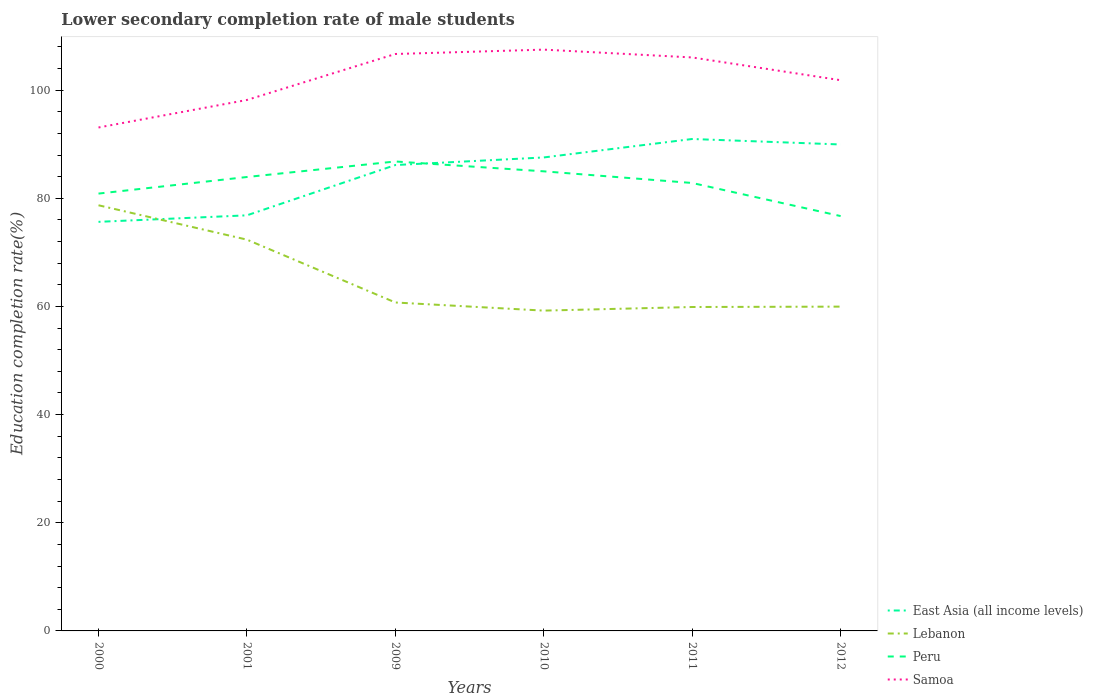How many different coloured lines are there?
Keep it short and to the point. 4. Across all years, what is the maximum lower secondary completion rate of male students in East Asia (all income levels)?
Ensure brevity in your answer.  75.64. In which year was the lower secondary completion rate of male students in East Asia (all income levels) maximum?
Keep it short and to the point. 2000. What is the total lower secondary completion rate of male students in East Asia (all income levels) in the graph?
Provide a short and direct response. -1.4. What is the difference between the highest and the second highest lower secondary completion rate of male students in Lebanon?
Ensure brevity in your answer.  19.48. What is the difference between two consecutive major ticks on the Y-axis?
Provide a short and direct response. 20. Are the values on the major ticks of Y-axis written in scientific E-notation?
Provide a succinct answer. No. Where does the legend appear in the graph?
Give a very brief answer. Bottom right. How many legend labels are there?
Your answer should be compact. 4. What is the title of the graph?
Keep it short and to the point. Lower secondary completion rate of male students. Does "Argentina" appear as one of the legend labels in the graph?
Provide a short and direct response. No. What is the label or title of the X-axis?
Make the answer very short. Years. What is the label or title of the Y-axis?
Provide a short and direct response. Education completion rate(%). What is the Education completion rate(%) in East Asia (all income levels) in 2000?
Make the answer very short. 75.64. What is the Education completion rate(%) of Lebanon in 2000?
Ensure brevity in your answer.  78.71. What is the Education completion rate(%) in Peru in 2000?
Your response must be concise. 80.87. What is the Education completion rate(%) of Samoa in 2000?
Ensure brevity in your answer.  93.09. What is the Education completion rate(%) in East Asia (all income levels) in 2001?
Provide a succinct answer. 76.84. What is the Education completion rate(%) of Lebanon in 2001?
Offer a very short reply. 72.35. What is the Education completion rate(%) in Peru in 2001?
Provide a short and direct response. 83.93. What is the Education completion rate(%) of Samoa in 2001?
Offer a terse response. 98.18. What is the Education completion rate(%) in East Asia (all income levels) in 2009?
Your response must be concise. 86.15. What is the Education completion rate(%) in Lebanon in 2009?
Provide a succinct answer. 60.73. What is the Education completion rate(%) in Peru in 2009?
Your answer should be very brief. 86.8. What is the Education completion rate(%) in Samoa in 2009?
Provide a succinct answer. 106.68. What is the Education completion rate(%) of East Asia (all income levels) in 2010?
Give a very brief answer. 87.55. What is the Education completion rate(%) of Lebanon in 2010?
Offer a terse response. 59.23. What is the Education completion rate(%) in Peru in 2010?
Keep it short and to the point. 84.98. What is the Education completion rate(%) of Samoa in 2010?
Provide a short and direct response. 107.49. What is the Education completion rate(%) in East Asia (all income levels) in 2011?
Make the answer very short. 90.96. What is the Education completion rate(%) in Lebanon in 2011?
Provide a succinct answer. 59.9. What is the Education completion rate(%) of Peru in 2011?
Your response must be concise. 82.83. What is the Education completion rate(%) in Samoa in 2011?
Ensure brevity in your answer.  106.04. What is the Education completion rate(%) in East Asia (all income levels) in 2012?
Your answer should be very brief. 89.95. What is the Education completion rate(%) in Lebanon in 2012?
Ensure brevity in your answer.  59.96. What is the Education completion rate(%) of Peru in 2012?
Give a very brief answer. 76.71. What is the Education completion rate(%) of Samoa in 2012?
Your answer should be compact. 101.83. Across all years, what is the maximum Education completion rate(%) of East Asia (all income levels)?
Provide a short and direct response. 90.96. Across all years, what is the maximum Education completion rate(%) of Lebanon?
Give a very brief answer. 78.71. Across all years, what is the maximum Education completion rate(%) in Peru?
Offer a very short reply. 86.8. Across all years, what is the maximum Education completion rate(%) in Samoa?
Offer a very short reply. 107.49. Across all years, what is the minimum Education completion rate(%) of East Asia (all income levels)?
Provide a short and direct response. 75.64. Across all years, what is the minimum Education completion rate(%) in Lebanon?
Your answer should be very brief. 59.23. Across all years, what is the minimum Education completion rate(%) in Peru?
Your answer should be very brief. 76.71. Across all years, what is the minimum Education completion rate(%) of Samoa?
Your answer should be very brief. 93.09. What is the total Education completion rate(%) in East Asia (all income levels) in the graph?
Your response must be concise. 507.09. What is the total Education completion rate(%) in Lebanon in the graph?
Provide a short and direct response. 390.87. What is the total Education completion rate(%) in Peru in the graph?
Ensure brevity in your answer.  496.12. What is the total Education completion rate(%) of Samoa in the graph?
Provide a succinct answer. 613.3. What is the difference between the Education completion rate(%) of East Asia (all income levels) in 2000 and that in 2001?
Offer a very short reply. -1.2. What is the difference between the Education completion rate(%) of Lebanon in 2000 and that in 2001?
Provide a succinct answer. 6.36. What is the difference between the Education completion rate(%) in Peru in 2000 and that in 2001?
Give a very brief answer. -3.07. What is the difference between the Education completion rate(%) of Samoa in 2000 and that in 2001?
Make the answer very short. -5.09. What is the difference between the Education completion rate(%) in East Asia (all income levels) in 2000 and that in 2009?
Offer a very short reply. -10.5. What is the difference between the Education completion rate(%) in Lebanon in 2000 and that in 2009?
Your answer should be very brief. 17.98. What is the difference between the Education completion rate(%) in Peru in 2000 and that in 2009?
Your answer should be very brief. -5.94. What is the difference between the Education completion rate(%) in Samoa in 2000 and that in 2009?
Ensure brevity in your answer.  -13.59. What is the difference between the Education completion rate(%) in East Asia (all income levels) in 2000 and that in 2010?
Offer a very short reply. -11.91. What is the difference between the Education completion rate(%) of Lebanon in 2000 and that in 2010?
Your response must be concise. 19.48. What is the difference between the Education completion rate(%) of Peru in 2000 and that in 2010?
Make the answer very short. -4.12. What is the difference between the Education completion rate(%) of Samoa in 2000 and that in 2010?
Offer a very short reply. -14.4. What is the difference between the Education completion rate(%) in East Asia (all income levels) in 2000 and that in 2011?
Your answer should be very brief. -15.32. What is the difference between the Education completion rate(%) of Lebanon in 2000 and that in 2011?
Give a very brief answer. 18.81. What is the difference between the Education completion rate(%) of Peru in 2000 and that in 2011?
Provide a short and direct response. -1.96. What is the difference between the Education completion rate(%) in Samoa in 2000 and that in 2011?
Provide a short and direct response. -12.95. What is the difference between the Education completion rate(%) of East Asia (all income levels) in 2000 and that in 2012?
Your answer should be compact. -14.31. What is the difference between the Education completion rate(%) of Lebanon in 2000 and that in 2012?
Offer a terse response. 18.74. What is the difference between the Education completion rate(%) of Peru in 2000 and that in 2012?
Provide a succinct answer. 4.16. What is the difference between the Education completion rate(%) in Samoa in 2000 and that in 2012?
Make the answer very short. -8.74. What is the difference between the Education completion rate(%) in East Asia (all income levels) in 2001 and that in 2009?
Keep it short and to the point. -9.3. What is the difference between the Education completion rate(%) in Lebanon in 2001 and that in 2009?
Provide a short and direct response. 11.62. What is the difference between the Education completion rate(%) in Peru in 2001 and that in 2009?
Make the answer very short. -2.87. What is the difference between the Education completion rate(%) in Samoa in 2001 and that in 2009?
Give a very brief answer. -8.5. What is the difference between the Education completion rate(%) of East Asia (all income levels) in 2001 and that in 2010?
Offer a terse response. -10.7. What is the difference between the Education completion rate(%) in Lebanon in 2001 and that in 2010?
Provide a short and direct response. 13.12. What is the difference between the Education completion rate(%) of Peru in 2001 and that in 2010?
Your answer should be very brief. -1.05. What is the difference between the Education completion rate(%) of Samoa in 2001 and that in 2010?
Your answer should be very brief. -9.31. What is the difference between the Education completion rate(%) of East Asia (all income levels) in 2001 and that in 2011?
Offer a terse response. -14.12. What is the difference between the Education completion rate(%) of Lebanon in 2001 and that in 2011?
Make the answer very short. 12.45. What is the difference between the Education completion rate(%) in Peru in 2001 and that in 2011?
Give a very brief answer. 1.11. What is the difference between the Education completion rate(%) in Samoa in 2001 and that in 2011?
Offer a very short reply. -7.86. What is the difference between the Education completion rate(%) in East Asia (all income levels) in 2001 and that in 2012?
Make the answer very short. -13.1. What is the difference between the Education completion rate(%) in Lebanon in 2001 and that in 2012?
Make the answer very short. 12.39. What is the difference between the Education completion rate(%) of Peru in 2001 and that in 2012?
Your response must be concise. 7.22. What is the difference between the Education completion rate(%) of Samoa in 2001 and that in 2012?
Your answer should be compact. -3.65. What is the difference between the Education completion rate(%) in East Asia (all income levels) in 2009 and that in 2010?
Your answer should be very brief. -1.4. What is the difference between the Education completion rate(%) of Lebanon in 2009 and that in 2010?
Provide a short and direct response. 1.5. What is the difference between the Education completion rate(%) in Peru in 2009 and that in 2010?
Provide a succinct answer. 1.82. What is the difference between the Education completion rate(%) of Samoa in 2009 and that in 2010?
Offer a terse response. -0.81. What is the difference between the Education completion rate(%) of East Asia (all income levels) in 2009 and that in 2011?
Ensure brevity in your answer.  -4.82. What is the difference between the Education completion rate(%) in Lebanon in 2009 and that in 2011?
Give a very brief answer. 0.83. What is the difference between the Education completion rate(%) of Peru in 2009 and that in 2011?
Offer a terse response. 3.98. What is the difference between the Education completion rate(%) in Samoa in 2009 and that in 2011?
Provide a succinct answer. 0.64. What is the difference between the Education completion rate(%) of East Asia (all income levels) in 2009 and that in 2012?
Offer a very short reply. -3.8. What is the difference between the Education completion rate(%) of Lebanon in 2009 and that in 2012?
Your answer should be compact. 0.77. What is the difference between the Education completion rate(%) in Peru in 2009 and that in 2012?
Your answer should be very brief. 10.1. What is the difference between the Education completion rate(%) of Samoa in 2009 and that in 2012?
Offer a terse response. 4.85. What is the difference between the Education completion rate(%) of East Asia (all income levels) in 2010 and that in 2011?
Provide a succinct answer. -3.41. What is the difference between the Education completion rate(%) of Lebanon in 2010 and that in 2011?
Your answer should be compact. -0.67. What is the difference between the Education completion rate(%) of Peru in 2010 and that in 2011?
Ensure brevity in your answer.  2.15. What is the difference between the Education completion rate(%) in Samoa in 2010 and that in 2011?
Your answer should be very brief. 1.45. What is the difference between the Education completion rate(%) of East Asia (all income levels) in 2010 and that in 2012?
Offer a terse response. -2.4. What is the difference between the Education completion rate(%) in Lebanon in 2010 and that in 2012?
Give a very brief answer. -0.74. What is the difference between the Education completion rate(%) of Peru in 2010 and that in 2012?
Keep it short and to the point. 8.27. What is the difference between the Education completion rate(%) of Samoa in 2010 and that in 2012?
Your answer should be compact. 5.66. What is the difference between the Education completion rate(%) in East Asia (all income levels) in 2011 and that in 2012?
Offer a very short reply. 1.01. What is the difference between the Education completion rate(%) of Lebanon in 2011 and that in 2012?
Provide a short and direct response. -0.07. What is the difference between the Education completion rate(%) of Peru in 2011 and that in 2012?
Ensure brevity in your answer.  6.12. What is the difference between the Education completion rate(%) of Samoa in 2011 and that in 2012?
Your answer should be compact. 4.21. What is the difference between the Education completion rate(%) of East Asia (all income levels) in 2000 and the Education completion rate(%) of Lebanon in 2001?
Keep it short and to the point. 3.29. What is the difference between the Education completion rate(%) of East Asia (all income levels) in 2000 and the Education completion rate(%) of Peru in 2001?
Your response must be concise. -8.29. What is the difference between the Education completion rate(%) in East Asia (all income levels) in 2000 and the Education completion rate(%) in Samoa in 2001?
Provide a succinct answer. -22.54. What is the difference between the Education completion rate(%) of Lebanon in 2000 and the Education completion rate(%) of Peru in 2001?
Offer a terse response. -5.23. What is the difference between the Education completion rate(%) of Lebanon in 2000 and the Education completion rate(%) of Samoa in 2001?
Offer a very short reply. -19.47. What is the difference between the Education completion rate(%) of Peru in 2000 and the Education completion rate(%) of Samoa in 2001?
Your response must be concise. -17.31. What is the difference between the Education completion rate(%) in East Asia (all income levels) in 2000 and the Education completion rate(%) in Lebanon in 2009?
Your answer should be very brief. 14.91. What is the difference between the Education completion rate(%) in East Asia (all income levels) in 2000 and the Education completion rate(%) in Peru in 2009?
Offer a very short reply. -11.16. What is the difference between the Education completion rate(%) in East Asia (all income levels) in 2000 and the Education completion rate(%) in Samoa in 2009?
Your answer should be compact. -31.04. What is the difference between the Education completion rate(%) in Lebanon in 2000 and the Education completion rate(%) in Peru in 2009?
Offer a terse response. -8.1. What is the difference between the Education completion rate(%) in Lebanon in 2000 and the Education completion rate(%) in Samoa in 2009?
Offer a very short reply. -27.97. What is the difference between the Education completion rate(%) of Peru in 2000 and the Education completion rate(%) of Samoa in 2009?
Ensure brevity in your answer.  -25.81. What is the difference between the Education completion rate(%) in East Asia (all income levels) in 2000 and the Education completion rate(%) in Lebanon in 2010?
Give a very brief answer. 16.42. What is the difference between the Education completion rate(%) in East Asia (all income levels) in 2000 and the Education completion rate(%) in Peru in 2010?
Your response must be concise. -9.34. What is the difference between the Education completion rate(%) in East Asia (all income levels) in 2000 and the Education completion rate(%) in Samoa in 2010?
Give a very brief answer. -31.84. What is the difference between the Education completion rate(%) of Lebanon in 2000 and the Education completion rate(%) of Peru in 2010?
Your answer should be very brief. -6.28. What is the difference between the Education completion rate(%) in Lebanon in 2000 and the Education completion rate(%) in Samoa in 2010?
Give a very brief answer. -28.78. What is the difference between the Education completion rate(%) in Peru in 2000 and the Education completion rate(%) in Samoa in 2010?
Offer a very short reply. -26.62. What is the difference between the Education completion rate(%) of East Asia (all income levels) in 2000 and the Education completion rate(%) of Lebanon in 2011?
Provide a succinct answer. 15.75. What is the difference between the Education completion rate(%) in East Asia (all income levels) in 2000 and the Education completion rate(%) in Peru in 2011?
Your answer should be very brief. -7.18. What is the difference between the Education completion rate(%) of East Asia (all income levels) in 2000 and the Education completion rate(%) of Samoa in 2011?
Give a very brief answer. -30.4. What is the difference between the Education completion rate(%) of Lebanon in 2000 and the Education completion rate(%) of Peru in 2011?
Provide a short and direct response. -4.12. What is the difference between the Education completion rate(%) of Lebanon in 2000 and the Education completion rate(%) of Samoa in 2011?
Ensure brevity in your answer.  -27.33. What is the difference between the Education completion rate(%) in Peru in 2000 and the Education completion rate(%) in Samoa in 2011?
Ensure brevity in your answer.  -25.17. What is the difference between the Education completion rate(%) of East Asia (all income levels) in 2000 and the Education completion rate(%) of Lebanon in 2012?
Provide a short and direct response. 15.68. What is the difference between the Education completion rate(%) of East Asia (all income levels) in 2000 and the Education completion rate(%) of Peru in 2012?
Provide a short and direct response. -1.07. What is the difference between the Education completion rate(%) in East Asia (all income levels) in 2000 and the Education completion rate(%) in Samoa in 2012?
Your answer should be very brief. -26.19. What is the difference between the Education completion rate(%) in Lebanon in 2000 and the Education completion rate(%) in Peru in 2012?
Give a very brief answer. 2. What is the difference between the Education completion rate(%) of Lebanon in 2000 and the Education completion rate(%) of Samoa in 2012?
Make the answer very short. -23.12. What is the difference between the Education completion rate(%) of Peru in 2000 and the Education completion rate(%) of Samoa in 2012?
Your answer should be compact. -20.96. What is the difference between the Education completion rate(%) of East Asia (all income levels) in 2001 and the Education completion rate(%) of Lebanon in 2009?
Your response must be concise. 16.12. What is the difference between the Education completion rate(%) of East Asia (all income levels) in 2001 and the Education completion rate(%) of Peru in 2009?
Keep it short and to the point. -9.96. What is the difference between the Education completion rate(%) in East Asia (all income levels) in 2001 and the Education completion rate(%) in Samoa in 2009?
Offer a terse response. -29.83. What is the difference between the Education completion rate(%) of Lebanon in 2001 and the Education completion rate(%) of Peru in 2009?
Ensure brevity in your answer.  -14.45. What is the difference between the Education completion rate(%) of Lebanon in 2001 and the Education completion rate(%) of Samoa in 2009?
Make the answer very short. -34.33. What is the difference between the Education completion rate(%) of Peru in 2001 and the Education completion rate(%) of Samoa in 2009?
Your response must be concise. -22.75. What is the difference between the Education completion rate(%) of East Asia (all income levels) in 2001 and the Education completion rate(%) of Lebanon in 2010?
Make the answer very short. 17.62. What is the difference between the Education completion rate(%) of East Asia (all income levels) in 2001 and the Education completion rate(%) of Peru in 2010?
Offer a very short reply. -8.14. What is the difference between the Education completion rate(%) of East Asia (all income levels) in 2001 and the Education completion rate(%) of Samoa in 2010?
Provide a succinct answer. -30.64. What is the difference between the Education completion rate(%) of Lebanon in 2001 and the Education completion rate(%) of Peru in 2010?
Provide a short and direct response. -12.63. What is the difference between the Education completion rate(%) in Lebanon in 2001 and the Education completion rate(%) in Samoa in 2010?
Offer a very short reply. -35.14. What is the difference between the Education completion rate(%) of Peru in 2001 and the Education completion rate(%) of Samoa in 2010?
Ensure brevity in your answer.  -23.55. What is the difference between the Education completion rate(%) of East Asia (all income levels) in 2001 and the Education completion rate(%) of Lebanon in 2011?
Give a very brief answer. 16.95. What is the difference between the Education completion rate(%) in East Asia (all income levels) in 2001 and the Education completion rate(%) in Peru in 2011?
Your answer should be compact. -5.98. What is the difference between the Education completion rate(%) of East Asia (all income levels) in 2001 and the Education completion rate(%) of Samoa in 2011?
Your answer should be very brief. -29.19. What is the difference between the Education completion rate(%) of Lebanon in 2001 and the Education completion rate(%) of Peru in 2011?
Your response must be concise. -10.48. What is the difference between the Education completion rate(%) in Lebanon in 2001 and the Education completion rate(%) in Samoa in 2011?
Your answer should be very brief. -33.69. What is the difference between the Education completion rate(%) of Peru in 2001 and the Education completion rate(%) of Samoa in 2011?
Your answer should be compact. -22.11. What is the difference between the Education completion rate(%) of East Asia (all income levels) in 2001 and the Education completion rate(%) of Lebanon in 2012?
Your response must be concise. 16.88. What is the difference between the Education completion rate(%) in East Asia (all income levels) in 2001 and the Education completion rate(%) in Peru in 2012?
Keep it short and to the point. 0.14. What is the difference between the Education completion rate(%) of East Asia (all income levels) in 2001 and the Education completion rate(%) of Samoa in 2012?
Give a very brief answer. -24.98. What is the difference between the Education completion rate(%) in Lebanon in 2001 and the Education completion rate(%) in Peru in 2012?
Your answer should be compact. -4.36. What is the difference between the Education completion rate(%) in Lebanon in 2001 and the Education completion rate(%) in Samoa in 2012?
Keep it short and to the point. -29.48. What is the difference between the Education completion rate(%) in Peru in 2001 and the Education completion rate(%) in Samoa in 2012?
Offer a very short reply. -17.9. What is the difference between the Education completion rate(%) of East Asia (all income levels) in 2009 and the Education completion rate(%) of Lebanon in 2010?
Provide a short and direct response. 26.92. What is the difference between the Education completion rate(%) of East Asia (all income levels) in 2009 and the Education completion rate(%) of Peru in 2010?
Keep it short and to the point. 1.16. What is the difference between the Education completion rate(%) of East Asia (all income levels) in 2009 and the Education completion rate(%) of Samoa in 2010?
Offer a very short reply. -21.34. What is the difference between the Education completion rate(%) in Lebanon in 2009 and the Education completion rate(%) in Peru in 2010?
Offer a terse response. -24.25. What is the difference between the Education completion rate(%) of Lebanon in 2009 and the Education completion rate(%) of Samoa in 2010?
Ensure brevity in your answer.  -46.76. What is the difference between the Education completion rate(%) in Peru in 2009 and the Education completion rate(%) in Samoa in 2010?
Offer a very short reply. -20.68. What is the difference between the Education completion rate(%) in East Asia (all income levels) in 2009 and the Education completion rate(%) in Lebanon in 2011?
Your answer should be very brief. 26.25. What is the difference between the Education completion rate(%) of East Asia (all income levels) in 2009 and the Education completion rate(%) of Peru in 2011?
Keep it short and to the point. 3.32. What is the difference between the Education completion rate(%) in East Asia (all income levels) in 2009 and the Education completion rate(%) in Samoa in 2011?
Ensure brevity in your answer.  -19.89. What is the difference between the Education completion rate(%) in Lebanon in 2009 and the Education completion rate(%) in Peru in 2011?
Provide a short and direct response. -22.1. What is the difference between the Education completion rate(%) of Lebanon in 2009 and the Education completion rate(%) of Samoa in 2011?
Ensure brevity in your answer.  -45.31. What is the difference between the Education completion rate(%) in Peru in 2009 and the Education completion rate(%) in Samoa in 2011?
Your answer should be very brief. -19.23. What is the difference between the Education completion rate(%) of East Asia (all income levels) in 2009 and the Education completion rate(%) of Lebanon in 2012?
Give a very brief answer. 26.18. What is the difference between the Education completion rate(%) of East Asia (all income levels) in 2009 and the Education completion rate(%) of Peru in 2012?
Make the answer very short. 9.44. What is the difference between the Education completion rate(%) of East Asia (all income levels) in 2009 and the Education completion rate(%) of Samoa in 2012?
Keep it short and to the point. -15.68. What is the difference between the Education completion rate(%) in Lebanon in 2009 and the Education completion rate(%) in Peru in 2012?
Your answer should be very brief. -15.98. What is the difference between the Education completion rate(%) in Lebanon in 2009 and the Education completion rate(%) in Samoa in 2012?
Your answer should be compact. -41.1. What is the difference between the Education completion rate(%) in Peru in 2009 and the Education completion rate(%) in Samoa in 2012?
Your answer should be compact. -15.03. What is the difference between the Education completion rate(%) of East Asia (all income levels) in 2010 and the Education completion rate(%) of Lebanon in 2011?
Your answer should be very brief. 27.65. What is the difference between the Education completion rate(%) of East Asia (all income levels) in 2010 and the Education completion rate(%) of Peru in 2011?
Make the answer very short. 4.72. What is the difference between the Education completion rate(%) in East Asia (all income levels) in 2010 and the Education completion rate(%) in Samoa in 2011?
Provide a short and direct response. -18.49. What is the difference between the Education completion rate(%) in Lebanon in 2010 and the Education completion rate(%) in Peru in 2011?
Give a very brief answer. -23.6. What is the difference between the Education completion rate(%) in Lebanon in 2010 and the Education completion rate(%) in Samoa in 2011?
Your answer should be compact. -46.81. What is the difference between the Education completion rate(%) in Peru in 2010 and the Education completion rate(%) in Samoa in 2011?
Your response must be concise. -21.06. What is the difference between the Education completion rate(%) in East Asia (all income levels) in 2010 and the Education completion rate(%) in Lebanon in 2012?
Your response must be concise. 27.58. What is the difference between the Education completion rate(%) of East Asia (all income levels) in 2010 and the Education completion rate(%) of Peru in 2012?
Give a very brief answer. 10.84. What is the difference between the Education completion rate(%) of East Asia (all income levels) in 2010 and the Education completion rate(%) of Samoa in 2012?
Keep it short and to the point. -14.28. What is the difference between the Education completion rate(%) in Lebanon in 2010 and the Education completion rate(%) in Peru in 2012?
Provide a short and direct response. -17.48. What is the difference between the Education completion rate(%) of Lebanon in 2010 and the Education completion rate(%) of Samoa in 2012?
Your answer should be very brief. -42.6. What is the difference between the Education completion rate(%) of Peru in 2010 and the Education completion rate(%) of Samoa in 2012?
Your answer should be very brief. -16.85. What is the difference between the Education completion rate(%) in East Asia (all income levels) in 2011 and the Education completion rate(%) in Lebanon in 2012?
Keep it short and to the point. 31. What is the difference between the Education completion rate(%) of East Asia (all income levels) in 2011 and the Education completion rate(%) of Peru in 2012?
Make the answer very short. 14.25. What is the difference between the Education completion rate(%) in East Asia (all income levels) in 2011 and the Education completion rate(%) in Samoa in 2012?
Your answer should be very brief. -10.87. What is the difference between the Education completion rate(%) of Lebanon in 2011 and the Education completion rate(%) of Peru in 2012?
Keep it short and to the point. -16.81. What is the difference between the Education completion rate(%) of Lebanon in 2011 and the Education completion rate(%) of Samoa in 2012?
Offer a terse response. -41.93. What is the difference between the Education completion rate(%) in Peru in 2011 and the Education completion rate(%) in Samoa in 2012?
Offer a very short reply. -19. What is the average Education completion rate(%) in East Asia (all income levels) per year?
Make the answer very short. 84.52. What is the average Education completion rate(%) in Lebanon per year?
Your answer should be compact. 65.15. What is the average Education completion rate(%) in Peru per year?
Ensure brevity in your answer.  82.69. What is the average Education completion rate(%) in Samoa per year?
Provide a succinct answer. 102.22. In the year 2000, what is the difference between the Education completion rate(%) of East Asia (all income levels) and Education completion rate(%) of Lebanon?
Keep it short and to the point. -3.06. In the year 2000, what is the difference between the Education completion rate(%) in East Asia (all income levels) and Education completion rate(%) in Peru?
Give a very brief answer. -5.22. In the year 2000, what is the difference between the Education completion rate(%) in East Asia (all income levels) and Education completion rate(%) in Samoa?
Provide a short and direct response. -17.45. In the year 2000, what is the difference between the Education completion rate(%) in Lebanon and Education completion rate(%) in Peru?
Offer a very short reply. -2.16. In the year 2000, what is the difference between the Education completion rate(%) of Lebanon and Education completion rate(%) of Samoa?
Offer a terse response. -14.38. In the year 2000, what is the difference between the Education completion rate(%) of Peru and Education completion rate(%) of Samoa?
Make the answer very short. -12.22. In the year 2001, what is the difference between the Education completion rate(%) of East Asia (all income levels) and Education completion rate(%) of Lebanon?
Keep it short and to the point. 4.5. In the year 2001, what is the difference between the Education completion rate(%) in East Asia (all income levels) and Education completion rate(%) in Peru?
Ensure brevity in your answer.  -7.09. In the year 2001, what is the difference between the Education completion rate(%) of East Asia (all income levels) and Education completion rate(%) of Samoa?
Ensure brevity in your answer.  -21.33. In the year 2001, what is the difference between the Education completion rate(%) in Lebanon and Education completion rate(%) in Peru?
Provide a short and direct response. -11.58. In the year 2001, what is the difference between the Education completion rate(%) in Lebanon and Education completion rate(%) in Samoa?
Provide a succinct answer. -25.83. In the year 2001, what is the difference between the Education completion rate(%) of Peru and Education completion rate(%) of Samoa?
Offer a terse response. -14.25. In the year 2009, what is the difference between the Education completion rate(%) of East Asia (all income levels) and Education completion rate(%) of Lebanon?
Ensure brevity in your answer.  25.42. In the year 2009, what is the difference between the Education completion rate(%) in East Asia (all income levels) and Education completion rate(%) in Peru?
Your answer should be very brief. -0.66. In the year 2009, what is the difference between the Education completion rate(%) of East Asia (all income levels) and Education completion rate(%) of Samoa?
Offer a very short reply. -20.53. In the year 2009, what is the difference between the Education completion rate(%) of Lebanon and Education completion rate(%) of Peru?
Provide a short and direct response. -26.08. In the year 2009, what is the difference between the Education completion rate(%) in Lebanon and Education completion rate(%) in Samoa?
Offer a terse response. -45.95. In the year 2009, what is the difference between the Education completion rate(%) of Peru and Education completion rate(%) of Samoa?
Your answer should be very brief. -19.87. In the year 2010, what is the difference between the Education completion rate(%) in East Asia (all income levels) and Education completion rate(%) in Lebanon?
Make the answer very short. 28.32. In the year 2010, what is the difference between the Education completion rate(%) in East Asia (all income levels) and Education completion rate(%) in Peru?
Your answer should be very brief. 2.57. In the year 2010, what is the difference between the Education completion rate(%) in East Asia (all income levels) and Education completion rate(%) in Samoa?
Your answer should be very brief. -19.94. In the year 2010, what is the difference between the Education completion rate(%) of Lebanon and Education completion rate(%) of Peru?
Ensure brevity in your answer.  -25.75. In the year 2010, what is the difference between the Education completion rate(%) in Lebanon and Education completion rate(%) in Samoa?
Your answer should be compact. -48.26. In the year 2010, what is the difference between the Education completion rate(%) in Peru and Education completion rate(%) in Samoa?
Ensure brevity in your answer.  -22.5. In the year 2011, what is the difference between the Education completion rate(%) in East Asia (all income levels) and Education completion rate(%) in Lebanon?
Offer a terse response. 31.07. In the year 2011, what is the difference between the Education completion rate(%) of East Asia (all income levels) and Education completion rate(%) of Peru?
Your answer should be compact. 8.13. In the year 2011, what is the difference between the Education completion rate(%) in East Asia (all income levels) and Education completion rate(%) in Samoa?
Keep it short and to the point. -15.08. In the year 2011, what is the difference between the Education completion rate(%) in Lebanon and Education completion rate(%) in Peru?
Make the answer very short. -22.93. In the year 2011, what is the difference between the Education completion rate(%) of Lebanon and Education completion rate(%) of Samoa?
Your response must be concise. -46.14. In the year 2011, what is the difference between the Education completion rate(%) in Peru and Education completion rate(%) in Samoa?
Keep it short and to the point. -23.21. In the year 2012, what is the difference between the Education completion rate(%) in East Asia (all income levels) and Education completion rate(%) in Lebanon?
Give a very brief answer. 29.98. In the year 2012, what is the difference between the Education completion rate(%) in East Asia (all income levels) and Education completion rate(%) in Peru?
Provide a succinct answer. 13.24. In the year 2012, what is the difference between the Education completion rate(%) in East Asia (all income levels) and Education completion rate(%) in Samoa?
Provide a succinct answer. -11.88. In the year 2012, what is the difference between the Education completion rate(%) in Lebanon and Education completion rate(%) in Peru?
Offer a very short reply. -16.74. In the year 2012, what is the difference between the Education completion rate(%) in Lebanon and Education completion rate(%) in Samoa?
Give a very brief answer. -41.87. In the year 2012, what is the difference between the Education completion rate(%) in Peru and Education completion rate(%) in Samoa?
Your answer should be very brief. -25.12. What is the ratio of the Education completion rate(%) in East Asia (all income levels) in 2000 to that in 2001?
Keep it short and to the point. 0.98. What is the ratio of the Education completion rate(%) of Lebanon in 2000 to that in 2001?
Keep it short and to the point. 1.09. What is the ratio of the Education completion rate(%) in Peru in 2000 to that in 2001?
Provide a short and direct response. 0.96. What is the ratio of the Education completion rate(%) in Samoa in 2000 to that in 2001?
Make the answer very short. 0.95. What is the ratio of the Education completion rate(%) in East Asia (all income levels) in 2000 to that in 2009?
Provide a succinct answer. 0.88. What is the ratio of the Education completion rate(%) in Lebanon in 2000 to that in 2009?
Provide a short and direct response. 1.3. What is the ratio of the Education completion rate(%) of Peru in 2000 to that in 2009?
Your response must be concise. 0.93. What is the ratio of the Education completion rate(%) of Samoa in 2000 to that in 2009?
Keep it short and to the point. 0.87. What is the ratio of the Education completion rate(%) of East Asia (all income levels) in 2000 to that in 2010?
Ensure brevity in your answer.  0.86. What is the ratio of the Education completion rate(%) of Lebanon in 2000 to that in 2010?
Keep it short and to the point. 1.33. What is the ratio of the Education completion rate(%) in Peru in 2000 to that in 2010?
Make the answer very short. 0.95. What is the ratio of the Education completion rate(%) of Samoa in 2000 to that in 2010?
Keep it short and to the point. 0.87. What is the ratio of the Education completion rate(%) in East Asia (all income levels) in 2000 to that in 2011?
Your answer should be very brief. 0.83. What is the ratio of the Education completion rate(%) in Lebanon in 2000 to that in 2011?
Your answer should be compact. 1.31. What is the ratio of the Education completion rate(%) of Peru in 2000 to that in 2011?
Your answer should be very brief. 0.98. What is the ratio of the Education completion rate(%) of Samoa in 2000 to that in 2011?
Your answer should be compact. 0.88. What is the ratio of the Education completion rate(%) in East Asia (all income levels) in 2000 to that in 2012?
Provide a succinct answer. 0.84. What is the ratio of the Education completion rate(%) in Lebanon in 2000 to that in 2012?
Your answer should be compact. 1.31. What is the ratio of the Education completion rate(%) in Peru in 2000 to that in 2012?
Offer a terse response. 1.05. What is the ratio of the Education completion rate(%) in Samoa in 2000 to that in 2012?
Your answer should be compact. 0.91. What is the ratio of the Education completion rate(%) in East Asia (all income levels) in 2001 to that in 2009?
Offer a terse response. 0.89. What is the ratio of the Education completion rate(%) in Lebanon in 2001 to that in 2009?
Your response must be concise. 1.19. What is the ratio of the Education completion rate(%) in Peru in 2001 to that in 2009?
Provide a short and direct response. 0.97. What is the ratio of the Education completion rate(%) of Samoa in 2001 to that in 2009?
Make the answer very short. 0.92. What is the ratio of the Education completion rate(%) in East Asia (all income levels) in 2001 to that in 2010?
Keep it short and to the point. 0.88. What is the ratio of the Education completion rate(%) of Lebanon in 2001 to that in 2010?
Give a very brief answer. 1.22. What is the ratio of the Education completion rate(%) in Peru in 2001 to that in 2010?
Your answer should be very brief. 0.99. What is the ratio of the Education completion rate(%) of Samoa in 2001 to that in 2010?
Make the answer very short. 0.91. What is the ratio of the Education completion rate(%) of East Asia (all income levels) in 2001 to that in 2011?
Keep it short and to the point. 0.84. What is the ratio of the Education completion rate(%) of Lebanon in 2001 to that in 2011?
Your answer should be very brief. 1.21. What is the ratio of the Education completion rate(%) of Peru in 2001 to that in 2011?
Your response must be concise. 1.01. What is the ratio of the Education completion rate(%) in Samoa in 2001 to that in 2011?
Ensure brevity in your answer.  0.93. What is the ratio of the Education completion rate(%) of East Asia (all income levels) in 2001 to that in 2012?
Make the answer very short. 0.85. What is the ratio of the Education completion rate(%) of Lebanon in 2001 to that in 2012?
Your response must be concise. 1.21. What is the ratio of the Education completion rate(%) in Peru in 2001 to that in 2012?
Your answer should be very brief. 1.09. What is the ratio of the Education completion rate(%) in Samoa in 2001 to that in 2012?
Your response must be concise. 0.96. What is the ratio of the Education completion rate(%) of East Asia (all income levels) in 2009 to that in 2010?
Your answer should be very brief. 0.98. What is the ratio of the Education completion rate(%) of Lebanon in 2009 to that in 2010?
Keep it short and to the point. 1.03. What is the ratio of the Education completion rate(%) in Peru in 2009 to that in 2010?
Your response must be concise. 1.02. What is the ratio of the Education completion rate(%) in Samoa in 2009 to that in 2010?
Ensure brevity in your answer.  0.99. What is the ratio of the Education completion rate(%) of East Asia (all income levels) in 2009 to that in 2011?
Your answer should be compact. 0.95. What is the ratio of the Education completion rate(%) in Lebanon in 2009 to that in 2011?
Make the answer very short. 1.01. What is the ratio of the Education completion rate(%) in Peru in 2009 to that in 2011?
Provide a succinct answer. 1.05. What is the ratio of the Education completion rate(%) of East Asia (all income levels) in 2009 to that in 2012?
Give a very brief answer. 0.96. What is the ratio of the Education completion rate(%) of Lebanon in 2009 to that in 2012?
Provide a short and direct response. 1.01. What is the ratio of the Education completion rate(%) of Peru in 2009 to that in 2012?
Keep it short and to the point. 1.13. What is the ratio of the Education completion rate(%) in Samoa in 2009 to that in 2012?
Your answer should be very brief. 1.05. What is the ratio of the Education completion rate(%) of East Asia (all income levels) in 2010 to that in 2011?
Your response must be concise. 0.96. What is the ratio of the Education completion rate(%) of Lebanon in 2010 to that in 2011?
Keep it short and to the point. 0.99. What is the ratio of the Education completion rate(%) of Peru in 2010 to that in 2011?
Your answer should be compact. 1.03. What is the ratio of the Education completion rate(%) of Samoa in 2010 to that in 2011?
Provide a short and direct response. 1.01. What is the ratio of the Education completion rate(%) of East Asia (all income levels) in 2010 to that in 2012?
Make the answer very short. 0.97. What is the ratio of the Education completion rate(%) of Lebanon in 2010 to that in 2012?
Provide a succinct answer. 0.99. What is the ratio of the Education completion rate(%) of Peru in 2010 to that in 2012?
Make the answer very short. 1.11. What is the ratio of the Education completion rate(%) in Samoa in 2010 to that in 2012?
Make the answer very short. 1.06. What is the ratio of the Education completion rate(%) in East Asia (all income levels) in 2011 to that in 2012?
Give a very brief answer. 1.01. What is the ratio of the Education completion rate(%) of Peru in 2011 to that in 2012?
Keep it short and to the point. 1.08. What is the ratio of the Education completion rate(%) in Samoa in 2011 to that in 2012?
Keep it short and to the point. 1.04. What is the difference between the highest and the second highest Education completion rate(%) in East Asia (all income levels)?
Ensure brevity in your answer.  1.01. What is the difference between the highest and the second highest Education completion rate(%) in Lebanon?
Your response must be concise. 6.36. What is the difference between the highest and the second highest Education completion rate(%) in Peru?
Your answer should be compact. 1.82. What is the difference between the highest and the second highest Education completion rate(%) in Samoa?
Keep it short and to the point. 0.81. What is the difference between the highest and the lowest Education completion rate(%) in East Asia (all income levels)?
Offer a very short reply. 15.32. What is the difference between the highest and the lowest Education completion rate(%) of Lebanon?
Your answer should be compact. 19.48. What is the difference between the highest and the lowest Education completion rate(%) of Peru?
Make the answer very short. 10.1. What is the difference between the highest and the lowest Education completion rate(%) in Samoa?
Your answer should be compact. 14.4. 